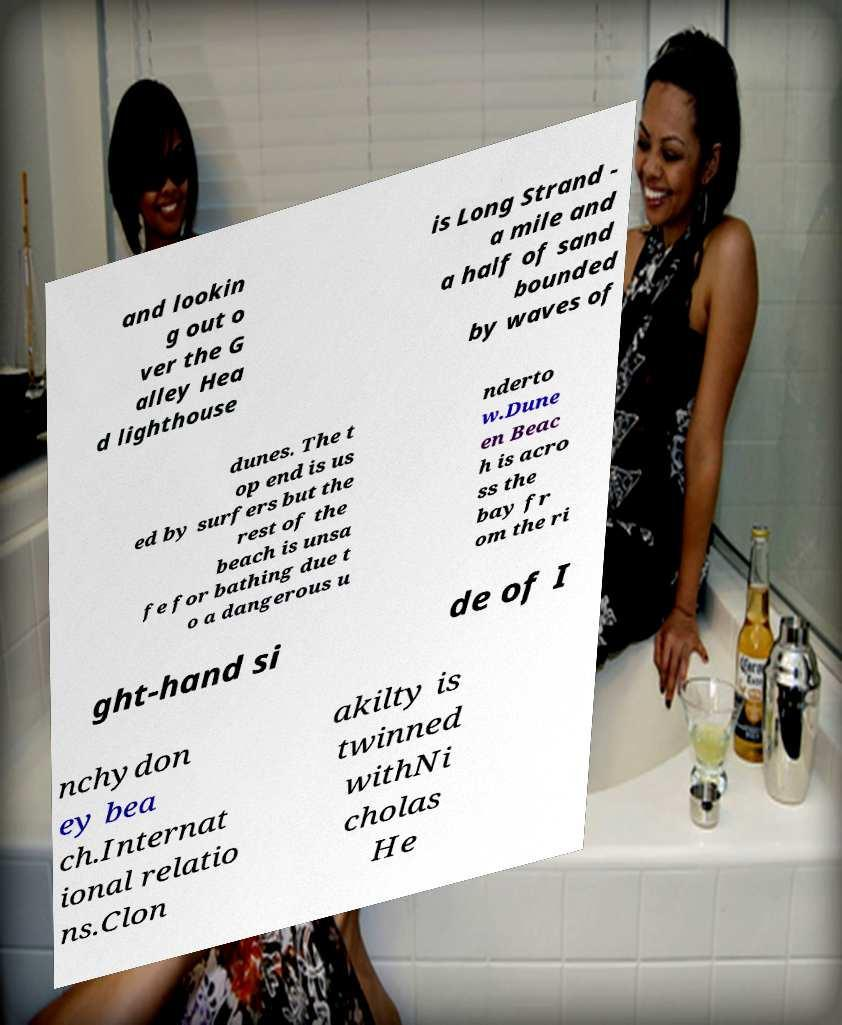Please read and relay the text visible in this image. What does it say? and lookin g out o ver the G alley Hea d lighthouse is Long Strand - a mile and a half of sand bounded by waves of dunes. The t op end is us ed by surfers but the rest of the beach is unsa fe for bathing due t o a dangerous u nderto w.Dune en Beac h is acro ss the bay fr om the ri ght-hand si de of I nchydon ey bea ch.Internat ional relatio ns.Clon akilty is twinned withNi cholas He 